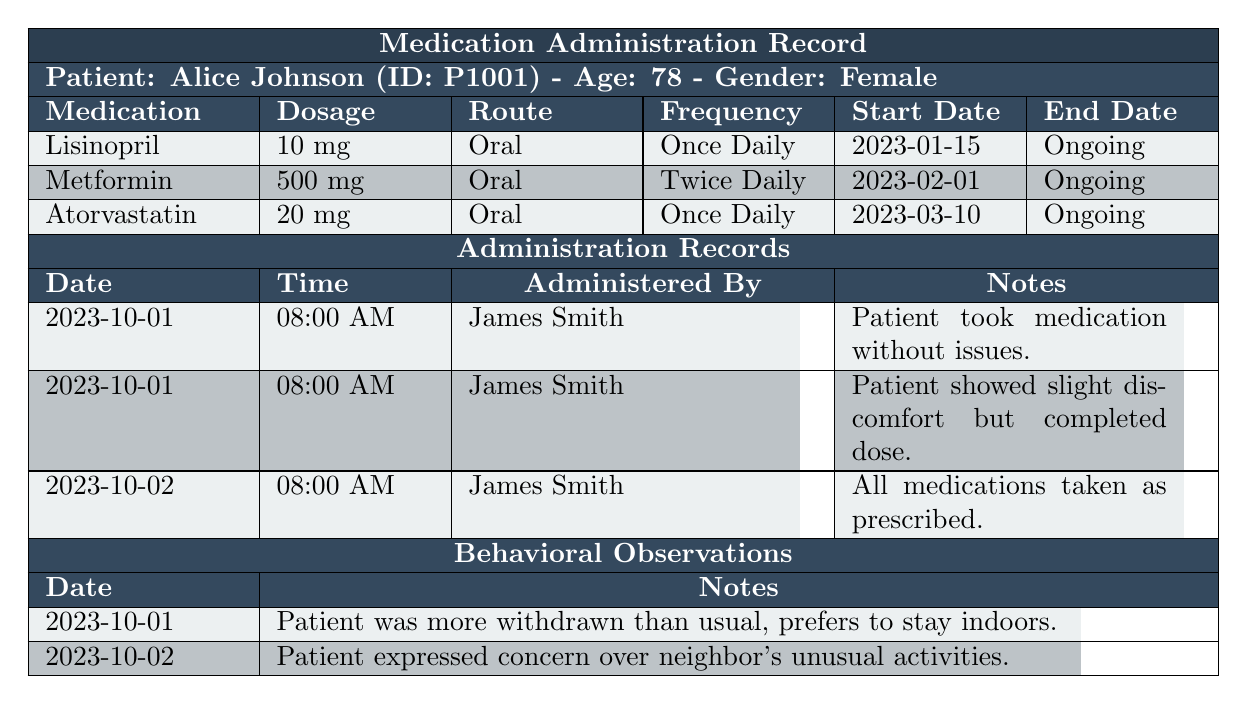What medications is Alice Johnson currently taking? The table lists three medications under "Medications": Lisinopril, Metformin, and Atorvastatin.
Answer: Lisinopril, Metformin, Atorvastatin How often is Metformin administered to Alice Johnson? The frequency of Metformin administration is noted as "Twice Daily" in the table.
Answer: Twice Daily What was recorded in the administration notes on October 1, 2023? There are two records for October 1, 2023, showing that the first note states the patient took medications without issues and the second note mentions slight discomfort.
Answer: Patient took medication without issues; Patient showed slight discomfort On which date did Alice express concern over her neighbor's unusual activities? The table indicates that Alice expressed this concern on October 2, 2023, in the "Observations" section.
Answer: October 2, 2023 What is the dosage of Lisinopril being prescribed to Alice? The prescribed dosage of Lisinopril listed in the "Medications" section is 10 mg.
Answer: 10 mg Was there ever a day when Alice reported discomfort while taking her medications? Yes, on October 1, 2023, it was noted that the patient showed slight discomfort while taking her medication.
Answer: Yes How many medications are Alice Johnson currently taking? The table shows that Alice is prescribed three medications: Lisinopril, Metformin, and Atorvastatin. Therefore, the count is 3.
Answer: 3 If Alice's Metformin is taken twice daily, how many doses does she take in a week? Since Metformin is taken twice daily, the weekly total would be 2 doses/day * 7 days/week = 14 doses/week.
Answer: 14 doses What was Alice’s behavior on October 1, 2023? The observation for that date notes that Alice was more withdrawn than usual and preferred to stay indoors.
Answer: More withdrawn; preferred to stay indoors Did Alice's emergency contact have any communication regarding her behavior? The table does not indicate any specific communication from her emergency contact regarding her behavior; only Alice's observations are provided.
Answer: No Which medication started first according to the records? The medication Lisinopril started on January 15, 2023, which is earlier than the other two medications (Metformin on February 1 and Atorvastatin on March 10).
Answer: Lisinopril What is the route of administration for Atorvastatin? Atorvastatin is administered orally, as specified in the "Medications" section of the table.
Answer: Oral Was there any mention of a specific individual administering Alice's medications? Yes, James Smith is noted as the individual who administered Alice's medications on the recorded dates.
Answer: Yes, James Smith How do Alice's behaviors on October 1 differ from those on October 2? On October 1, Alice was more reserved and preferred to stay indoors, but on October 2, she expressed concern over her neighbor's activities, indicating a change in her behavior and concern for her surroundings.
Answer: More withdrawn on October 1; Concerned about neighbor on October 2 